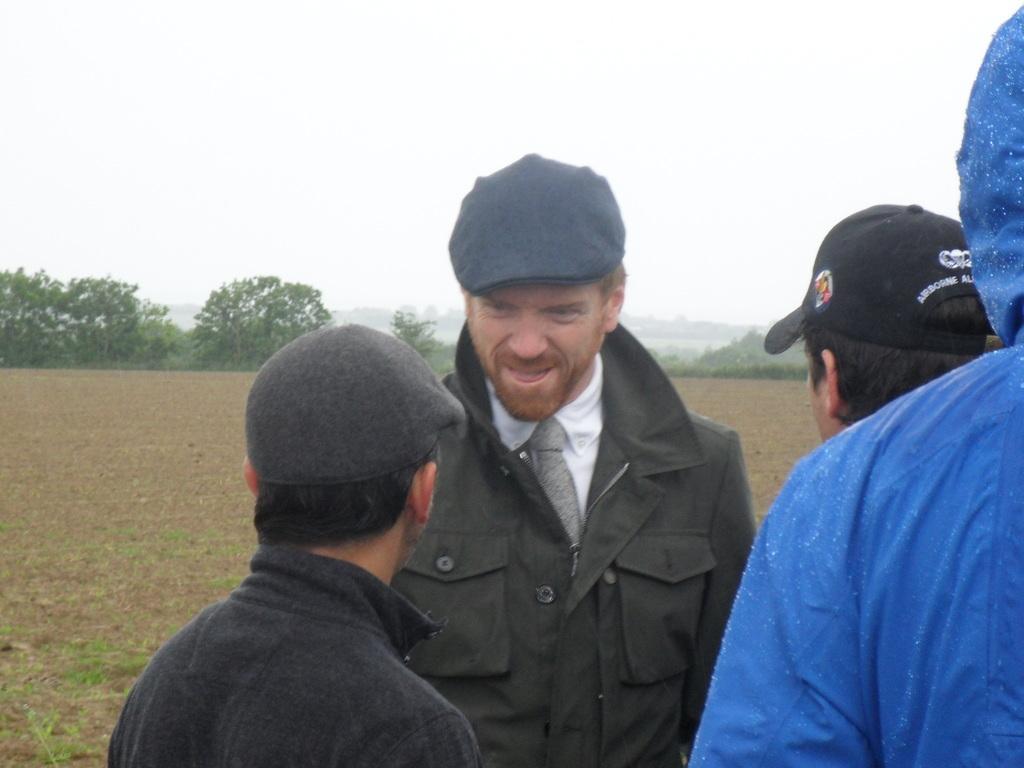Describe this image in one or two sentences. In front of the image there are four people standing. At the bottom of the image there is a sand on the surface. In the background of the image there are trees, mountains and sky. 